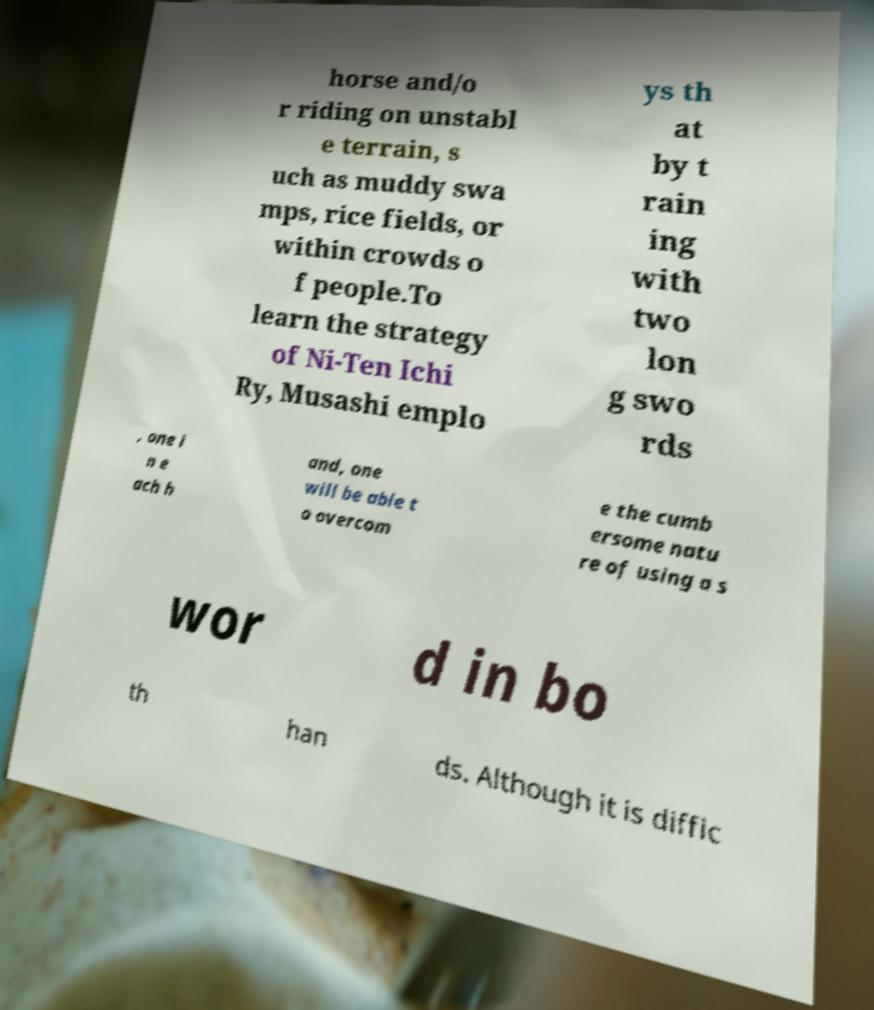For documentation purposes, I need the text within this image transcribed. Could you provide that? horse and/o r riding on unstabl e terrain, s uch as muddy swa mps, rice fields, or within crowds o f people.To learn the strategy of Ni-Ten Ichi Ry, Musashi emplo ys th at by t rain ing with two lon g swo rds , one i n e ach h and, one will be able t o overcom e the cumb ersome natu re of using a s wor d in bo th han ds. Although it is diffic 